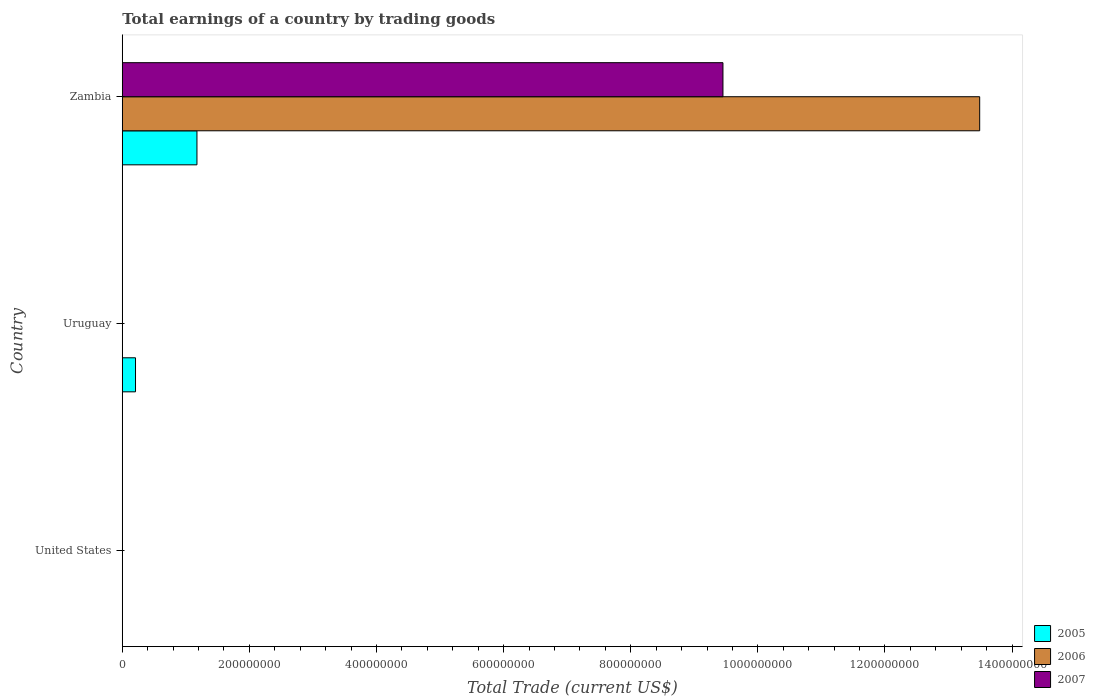How many bars are there on the 1st tick from the bottom?
Keep it short and to the point. 0. In how many cases, is the number of bars for a given country not equal to the number of legend labels?
Your answer should be compact. 2. Across all countries, what is the maximum total earnings in 2007?
Keep it short and to the point. 9.45e+08. Across all countries, what is the minimum total earnings in 2006?
Offer a terse response. 0. In which country was the total earnings in 2005 maximum?
Provide a short and direct response. Zambia. What is the total total earnings in 2006 in the graph?
Your response must be concise. 1.35e+09. What is the difference between the total earnings in 2005 in Uruguay and that in Zambia?
Your response must be concise. -9.67e+07. What is the difference between the total earnings in 2007 in United States and the total earnings in 2005 in Zambia?
Your response must be concise. -1.17e+08. What is the average total earnings in 2007 per country?
Offer a very short reply. 3.15e+08. What is the difference between the total earnings in 2006 and total earnings in 2005 in Zambia?
Your answer should be compact. 1.23e+09. What is the ratio of the total earnings in 2005 in Uruguay to that in Zambia?
Give a very brief answer. 0.18. What is the difference between the highest and the lowest total earnings in 2006?
Ensure brevity in your answer.  1.35e+09. In how many countries, is the total earnings in 2006 greater than the average total earnings in 2006 taken over all countries?
Make the answer very short. 1. Is the sum of the total earnings in 2005 in Uruguay and Zambia greater than the maximum total earnings in 2006 across all countries?
Keep it short and to the point. No. How many bars are there?
Offer a very short reply. 4. How many countries are there in the graph?
Provide a succinct answer. 3. Are the values on the major ticks of X-axis written in scientific E-notation?
Offer a very short reply. No. How many legend labels are there?
Your answer should be very brief. 3. What is the title of the graph?
Make the answer very short. Total earnings of a country by trading goods. Does "2008" appear as one of the legend labels in the graph?
Keep it short and to the point. No. What is the label or title of the X-axis?
Make the answer very short. Total Trade (current US$). What is the label or title of the Y-axis?
Your answer should be compact. Country. What is the Total Trade (current US$) in 2006 in United States?
Your answer should be very brief. 0. What is the Total Trade (current US$) of 2007 in United States?
Offer a very short reply. 0. What is the Total Trade (current US$) of 2005 in Uruguay?
Your answer should be compact. 2.08e+07. What is the Total Trade (current US$) of 2007 in Uruguay?
Keep it short and to the point. 0. What is the Total Trade (current US$) in 2005 in Zambia?
Your answer should be very brief. 1.17e+08. What is the Total Trade (current US$) of 2006 in Zambia?
Your answer should be very brief. 1.35e+09. What is the Total Trade (current US$) of 2007 in Zambia?
Your answer should be compact. 9.45e+08. Across all countries, what is the maximum Total Trade (current US$) in 2005?
Your answer should be very brief. 1.17e+08. Across all countries, what is the maximum Total Trade (current US$) of 2006?
Ensure brevity in your answer.  1.35e+09. Across all countries, what is the maximum Total Trade (current US$) of 2007?
Your answer should be very brief. 9.45e+08. Across all countries, what is the minimum Total Trade (current US$) of 2005?
Your answer should be very brief. 0. Across all countries, what is the minimum Total Trade (current US$) of 2007?
Give a very brief answer. 0. What is the total Total Trade (current US$) in 2005 in the graph?
Provide a short and direct response. 1.38e+08. What is the total Total Trade (current US$) in 2006 in the graph?
Make the answer very short. 1.35e+09. What is the total Total Trade (current US$) of 2007 in the graph?
Your answer should be very brief. 9.45e+08. What is the difference between the Total Trade (current US$) of 2005 in Uruguay and that in Zambia?
Make the answer very short. -9.67e+07. What is the difference between the Total Trade (current US$) of 2005 in Uruguay and the Total Trade (current US$) of 2006 in Zambia?
Give a very brief answer. -1.33e+09. What is the difference between the Total Trade (current US$) in 2005 in Uruguay and the Total Trade (current US$) in 2007 in Zambia?
Provide a short and direct response. -9.24e+08. What is the average Total Trade (current US$) in 2005 per country?
Offer a very short reply. 4.61e+07. What is the average Total Trade (current US$) in 2006 per country?
Provide a short and direct response. 4.50e+08. What is the average Total Trade (current US$) in 2007 per country?
Your answer should be very brief. 3.15e+08. What is the difference between the Total Trade (current US$) in 2005 and Total Trade (current US$) in 2006 in Zambia?
Keep it short and to the point. -1.23e+09. What is the difference between the Total Trade (current US$) of 2005 and Total Trade (current US$) of 2007 in Zambia?
Keep it short and to the point. -8.28e+08. What is the difference between the Total Trade (current US$) in 2006 and Total Trade (current US$) in 2007 in Zambia?
Make the answer very short. 4.04e+08. What is the ratio of the Total Trade (current US$) in 2005 in Uruguay to that in Zambia?
Give a very brief answer. 0.18. What is the difference between the highest and the lowest Total Trade (current US$) of 2005?
Provide a short and direct response. 1.17e+08. What is the difference between the highest and the lowest Total Trade (current US$) of 2006?
Your answer should be compact. 1.35e+09. What is the difference between the highest and the lowest Total Trade (current US$) of 2007?
Provide a short and direct response. 9.45e+08. 